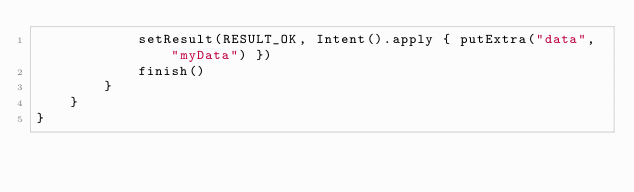Convert code to text. <code><loc_0><loc_0><loc_500><loc_500><_Kotlin_>            setResult(RESULT_OK, Intent().apply { putExtra("data", "myData") })
            finish()
        }
    }
}</code> 